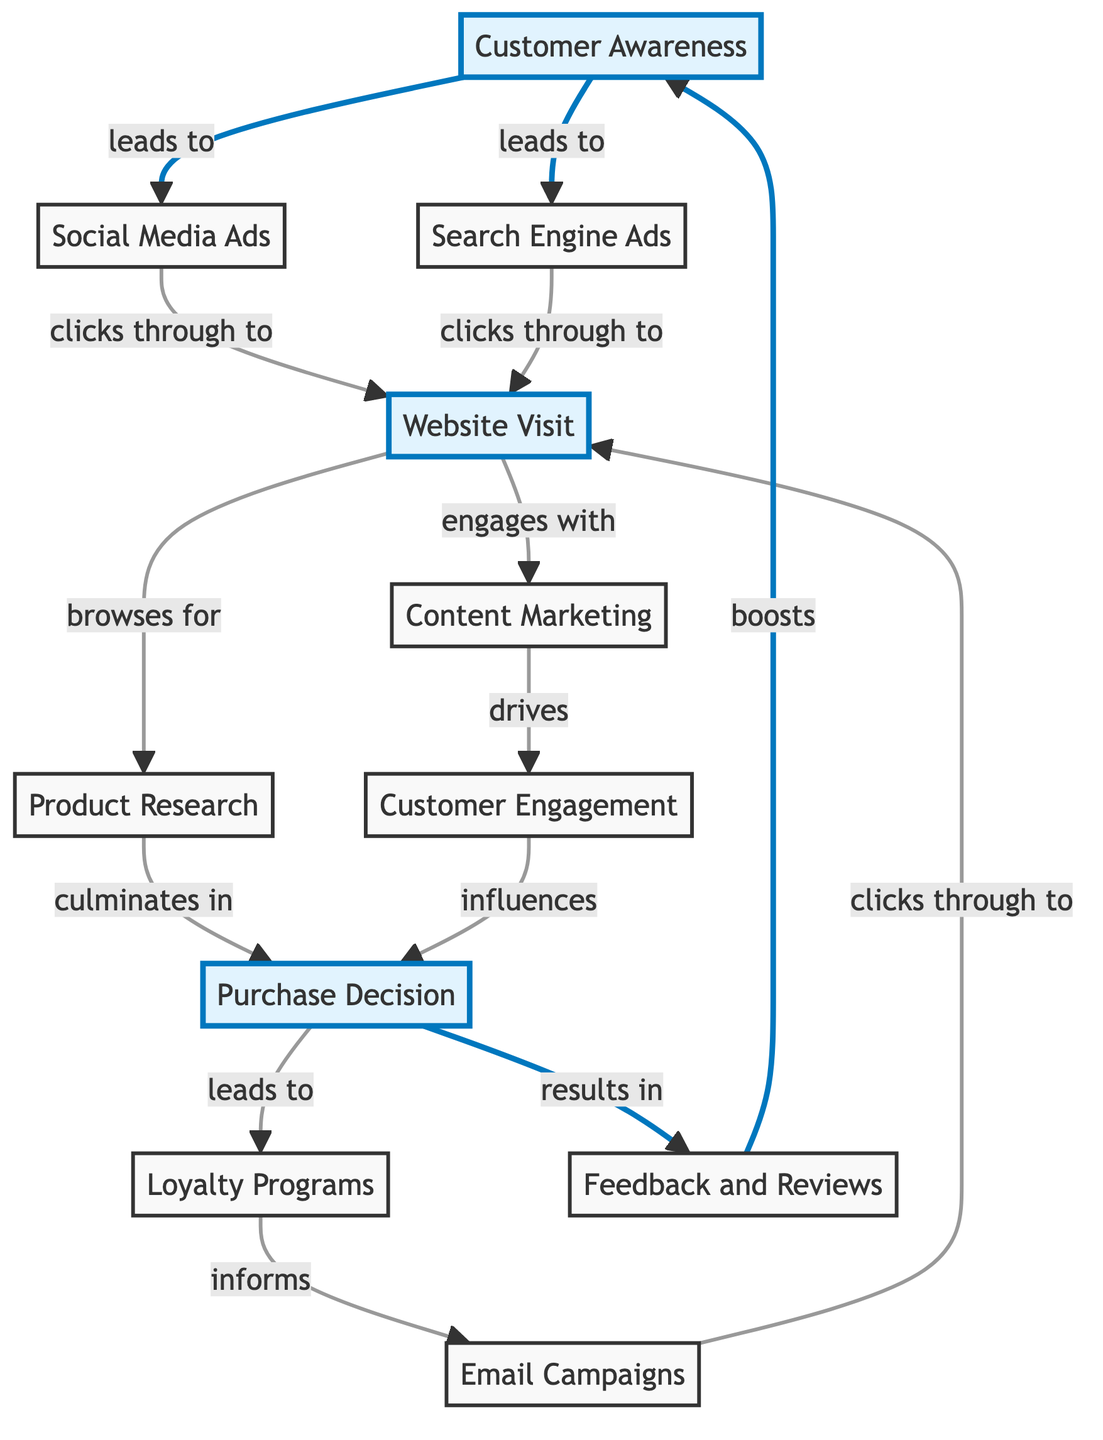What's the total number of nodes in the diagram? The diagram shows 11 distinct nodes representing various stages in the customer journey and touchpoints in digital advertising.
Answer: 11 What is the relationship between "Customer Awareness" and "Social Media Ads"? The diagram indicates that "Customer Awareness" leads to "Social Media Ads" as part of the initial awareness phase.
Answer: leads to Which node follows "Website Visit" in the sequence? After "Website Visit," the next nodes that can be engaged with are "Content Marketing" and "Product Research," showing two paths that can be taken.
Answer: Content Marketing and Product Research How many edges are there connecting nodes in the diagram? The diagram has 13 edges that define the relationships and flow between the different stages and touchpoints of the customer journey.
Answer: 13 What influences the "Purchase Decision"? The "Purchase Decision" is influenced by "Customer Engagement" and also culminates from "Product Research," indicating multiple factors lead to this decision.
Answer: Customer Engagement and Product Research Which node culminates in the "Purchase Decision"? The node that directly culminates in the "Purchase Decision" is "Product Research," as customers investigate facts before deciding to buy.
Answer: Product Research What is the effect of "Feedback and Reviews" on "Customer Awareness"? "Feedback and Reviews" have a positive effect as they boost "Customer Awareness," indicating that reviews can enhance brand visibility.
Answer: boosts What leads to the "Loyalty Programs"? The "Purchase Decision" leads to "Loyalty Programs," suggesting that once a customer decides to buy, they are offered loyalty incentives.
Answer: leads to Which nodes are connected directly by "Email Campaigns"? "Email Campaigns" connects directly to "Website Visit," indicating that emails drive traffic to the website.
Answer: Website Visit 